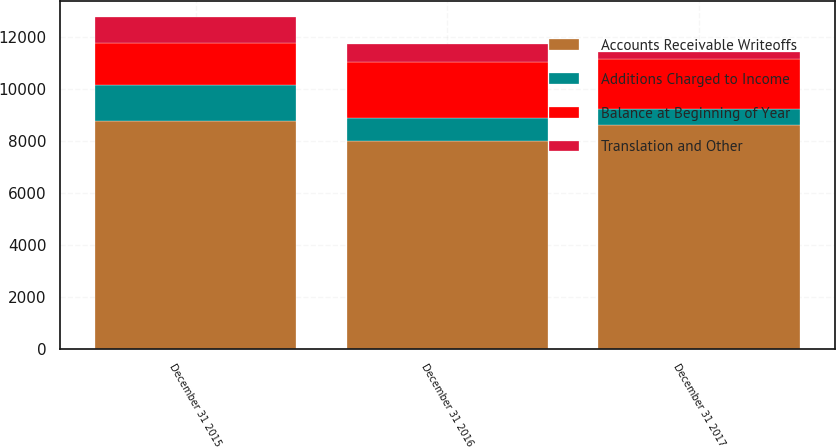<chart> <loc_0><loc_0><loc_500><loc_500><stacked_bar_chart><ecel><fcel>December 31 2017<fcel>December 31 2016<fcel>December 31 2015<nl><fcel>Accounts Receivable Writeoffs<fcel>8636<fcel>8026<fcel>8783<nl><fcel>Balance at Beginning of Year<fcel>1949<fcel>2156<fcel>1618<nl><fcel>Additions Charged to Income<fcel>596<fcel>862<fcel>1387<nl><fcel>Translation and Other<fcel>266<fcel>684<fcel>988<nl></chart> 